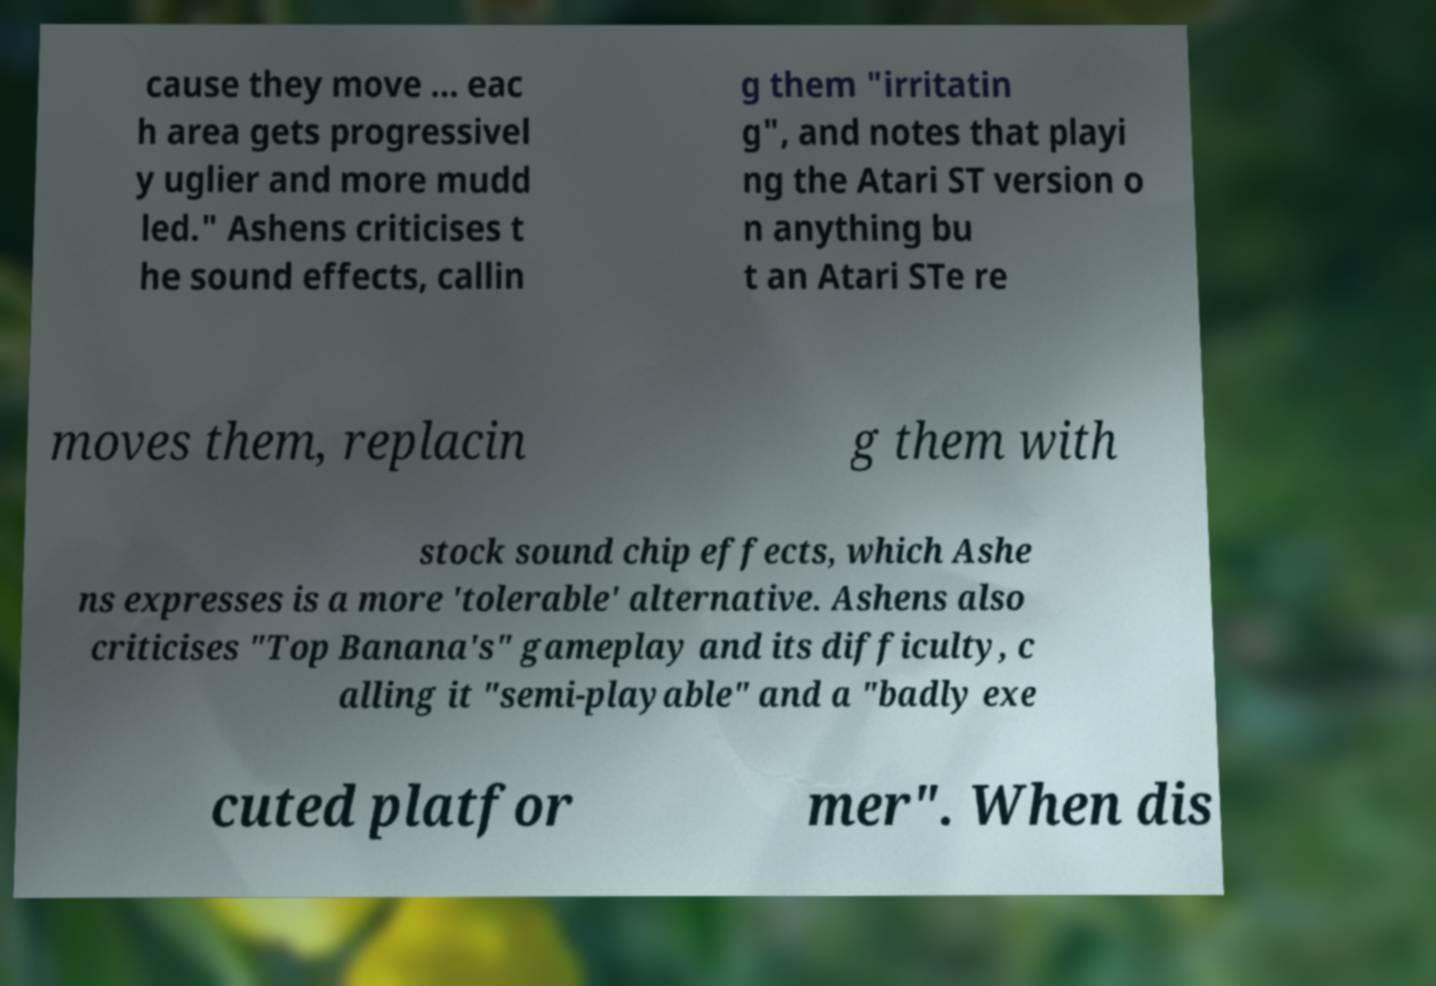Please read and relay the text visible in this image. What does it say? cause they move ... eac h area gets progressivel y uglier and more mudd led." Ashens criticises t he sound effects, callin g them "irritatin g", and notes that playi ng the Atari ST version o n anything bu t an Atari STe re moves them, replacin g them with stock sound chip effects, which Ashe ns expresses is a more 'tolerable' alternative. Ashens also criticises "Top Banana's" gameplay and its difficulty, c alling it "semi-playable" and a "badly exe cuted platfor mer". When dis 